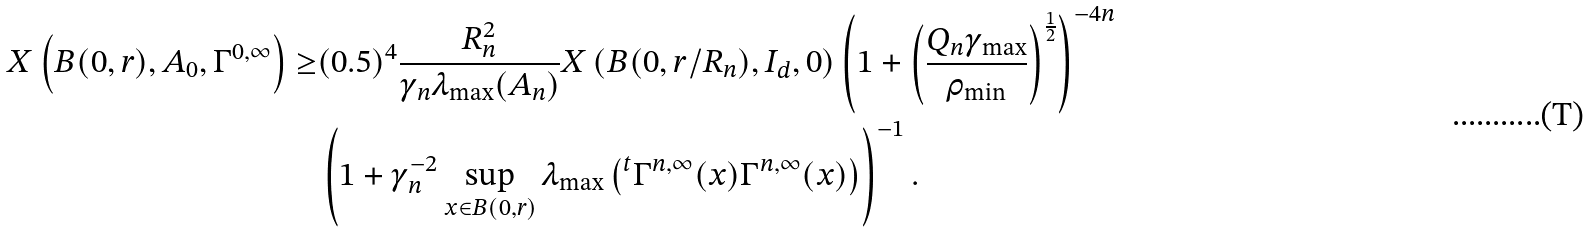<formula> <loc_0><loc_0><loc_500><loc_500>X \left ( B ( 0 , r ) , A _ { 0 } , \Gamma ^ { 0 , \infty } \right ) \geq & ( 0 . 5 ) ^ { 4 } \frac { R _ { n } ^ { 2 } } { \gamma _ { n } \lambda _ { \max } ( A _ { n } ) } X \left ( B ( 0 , r / R _ { n } ) , I _ { d } , 0 \right ) \left ( 1 + \left ( \frac { Q _ { n } \gamma _ { \max } } { \rho _ { \min } } \right ) ^ { \frac { 1 } { 2 } } \right ) ^ { - 4 n } \\ & \left ( 1 + \gamma _ { n } ^ { - 2 } \sup _ { x \in B ( 0 , r ) } \lambda _ { \max } \left ( { ^ { t } \Gamma ^ { n , \infty } ( x ) \Gamma ^ { n , \infty } ( x ) } \right ) \right ) ^ { - 1 } .</formula> 